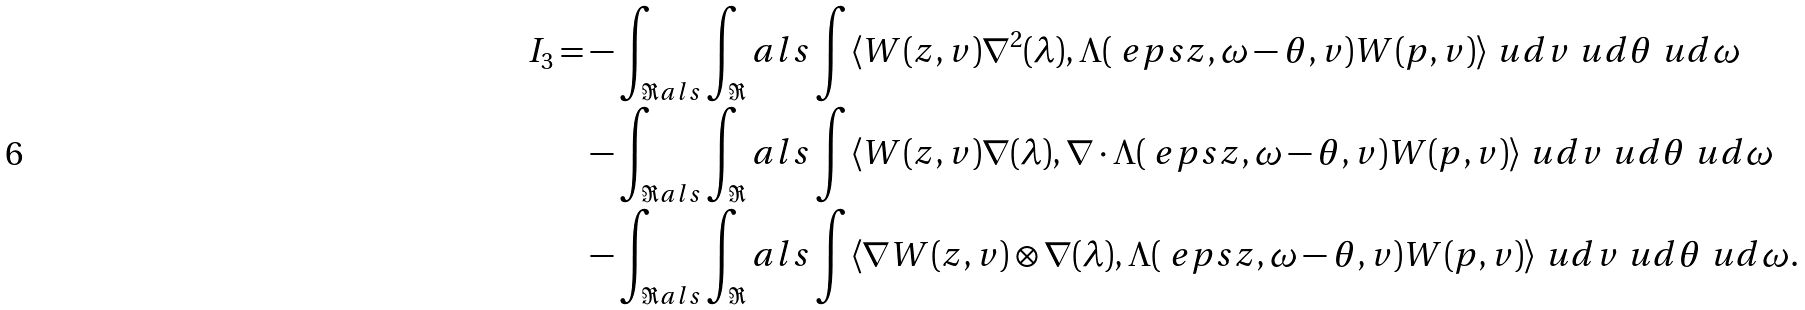Convert formula to latex. <formula><loc_0><loc_0><loc_500><loc_500>I _ { 3 } = & - \int _ { \Re a l s } \int _ { \Re } a l s \int \langle W ( z , v ) \nabla ^ { 2 } ( \lambda ) , \Lambda ( \ e p s z , \omega - \theta , v ) W ( p , v ) \rangle \ u d { v } \ u d { \theta } \ u d { \omega } \\ & - \int _ { \Re a l s } \int _ { \Re } a l s \int \langle W ( z , v ) \nabla ( \lambda ) , \nabla \cdot \Lambda ( \ e p s z , \omega - \theta , v ) W ( p , v ) \rangle \ u d { v } \ u d { \theta } \ u d { \omega } \\ & - \int _ { \Re a l s } \int _ { \Re } a l s \int \langle \nabla W ( z , v ) \otimes \nabla ( \lambda ) , \Lambda ( \ e p s z , \omega - \theta , v ) W ( p , v ) \rangle \ u d { v } \ u d { \theta } \ u d { \omega } .</formula> 